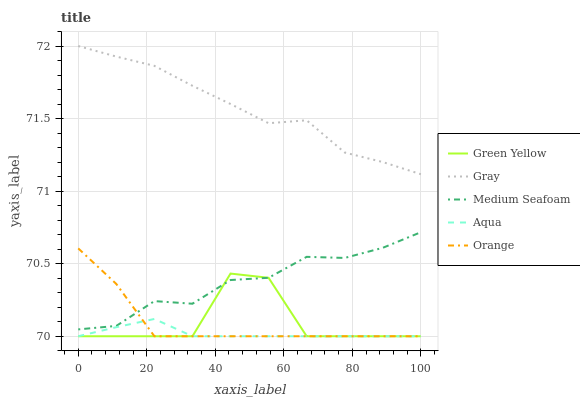Does Aqua have the minimum area under the curve?
Answer yes or no. Yes. Does Gray have the maximum area under the curve?
Answer yes or no. Yes. Does Green Yellow have the minimum area under the curve?
Answer yes or no. No. Does Green Yellow have the maximum area under the curve?
Answer yes or no. No. Is Aqua the smoothest?
Answer yes or no. Yes. Is Green Yellow the roughest?
Answer yes or no. Yes. Is Gray the smoothest?
Answer yes or no. No. Is Gray the roughest?
Answer yes or no. No. Does Gray have the lowest value?
Answer yes or no. No. Does Gray have the highest value?
Answer yes or no. Yes. Does Green Yellow have the highest value?
Answer yes or no. No. Is Aqua less than Medium Seafoam?
Answer yes or no. Yes. Is Medium Seafoam greater than Aqua?
Answer yes or no. Yes. Does Aqua intersect Green Yellow?
Answer yes or no. Yes. Is Aqua less than Green Yellow?
Answer yes or no. No. Is Aqua greater than Green Yellow?
Answer yes or no. No. Does Aqua intersect Medium Seafoam?
Answer yes or no. No. 